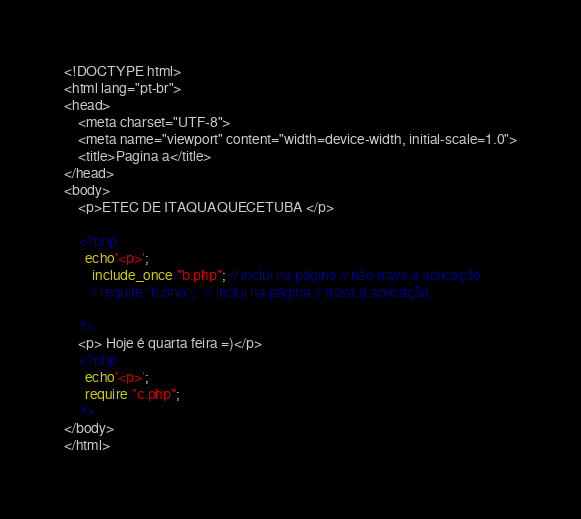<code> <loc_0><loc_0><loc_500><loc_500><_PHP_><!DOCTYPE html>
<html lang="pt-br">
<head>
    <meta charset="UTF-8">
    <meta name="viewport" content="width=device-width, initial-scale=1.0">
    <title>Pagina a</title>
</head>
<body>
    <p>ETEC DE ITAQUAQUECETUBA </p>
    
    <?php
      echo'<p>';
        include_once "b.php"; // inclui na página // não trava a aplicação
       // require "b.php";   // inclui na página // trava a aplicação
    
    ?>
    <p> Hoje é quarta feira =)</p>
    <?php
      echo'<p>';
      require "c.php";
    ?>
</body>
</html></code> 